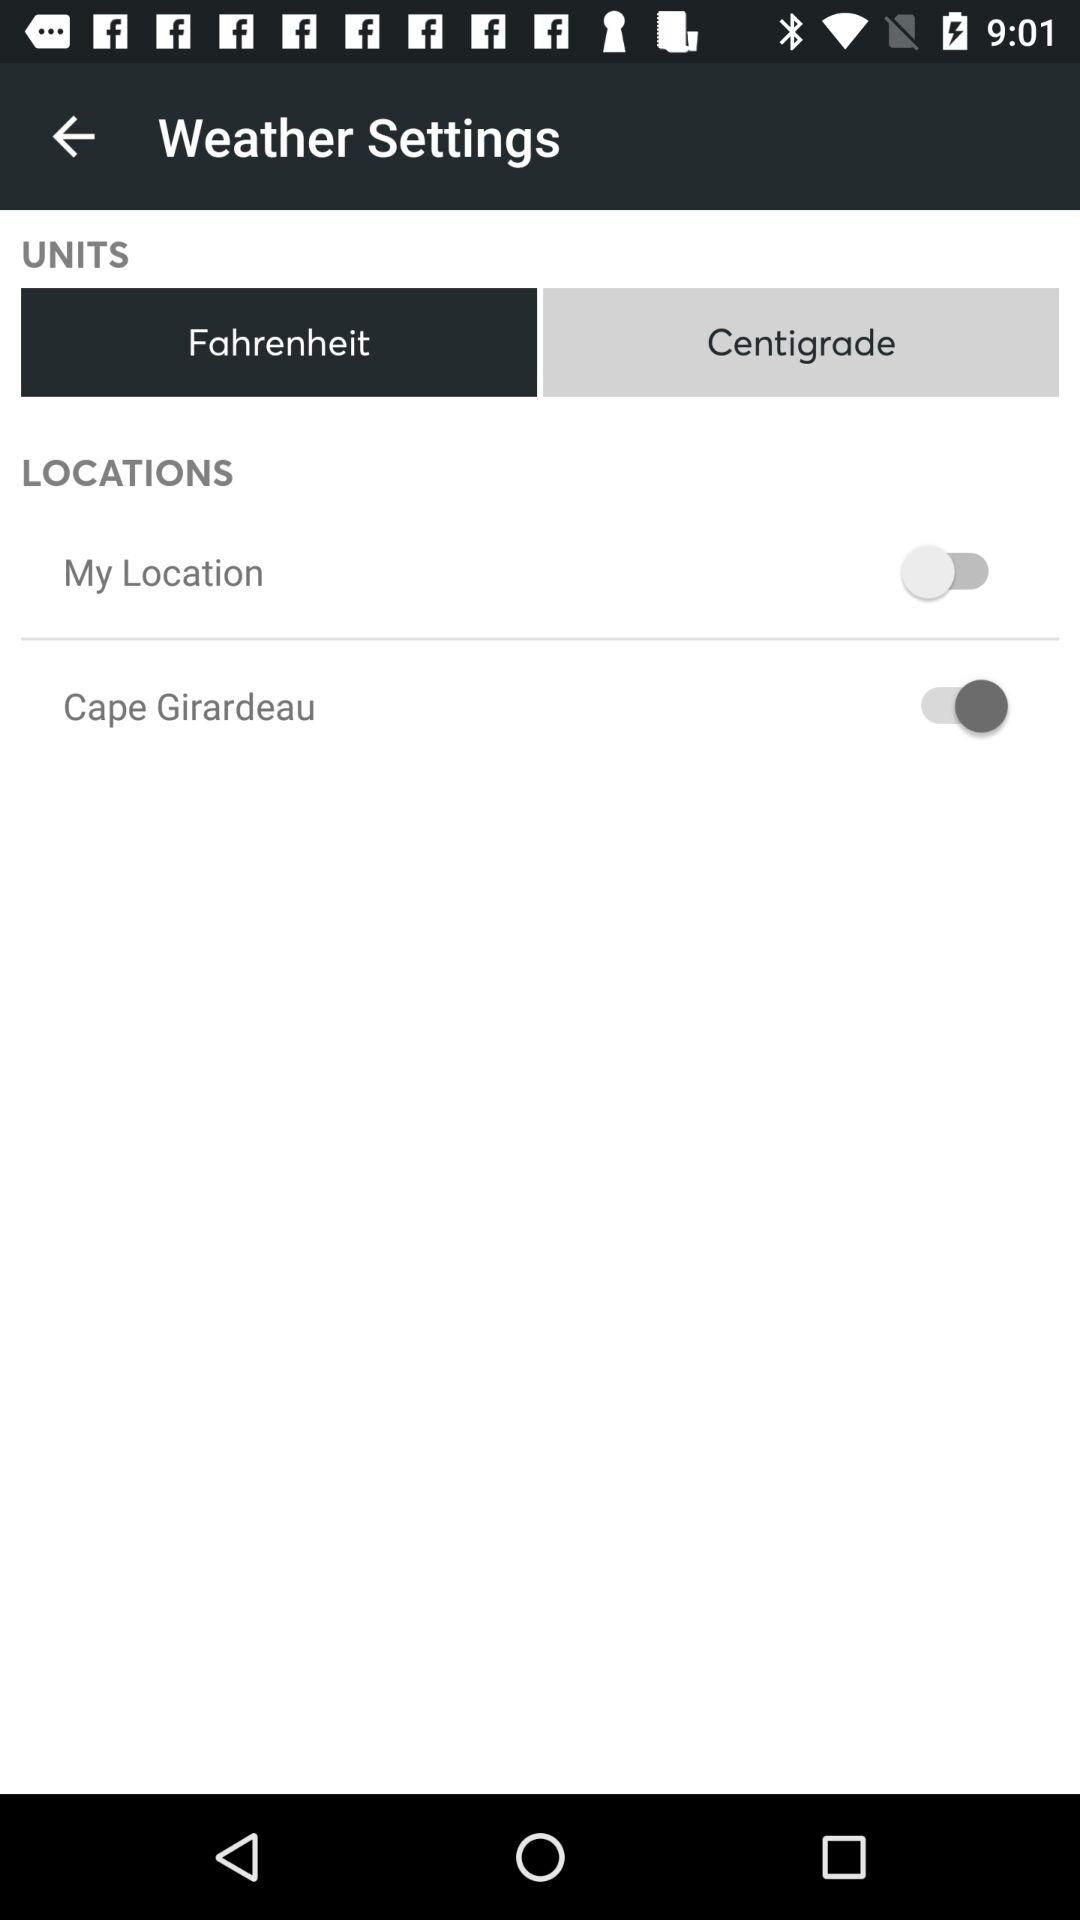How many locations are there?
Answer the question using a single word or phrase. 2 